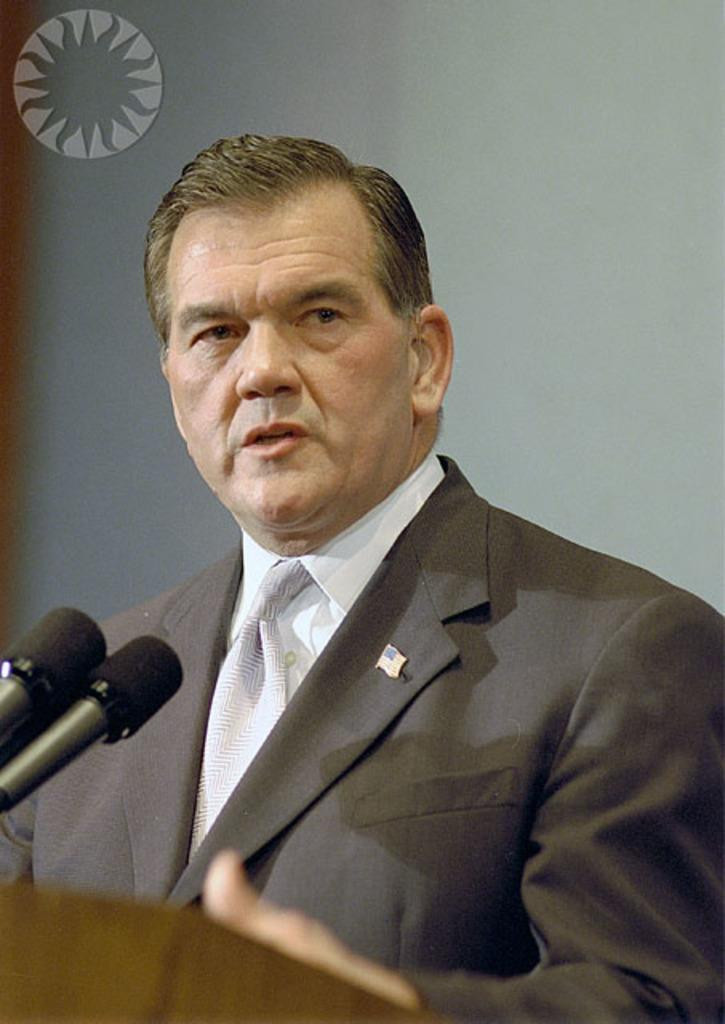Who is the main subject in the image? There is a man in the image. What is the man wearing in the image? The man is wearing a blazer and a tie in the image. What is the man doing in the image? The man is standing at a podium and talking on a microphone in the image. What type of alley can be seen behind the man in the image? There is no alley visible in the image; it is focused on the man at the podium. 